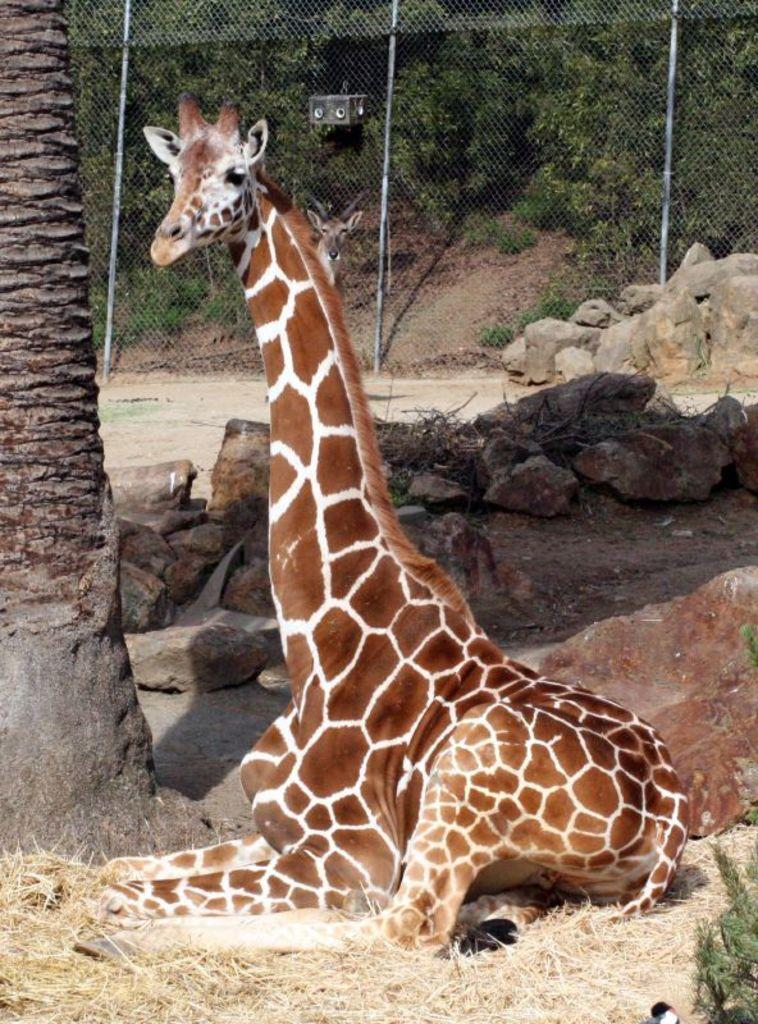What type of animal can be seen in the image? There is a giraffe in the image. What type of vegetation is visible in the image? Dry grass and plants are present in the image. What other objects can be seen in the image? Stones and a mesh are visible in the image. What part of a tree is visible in the image? A tree trunk is visible in the image. What year is depicted in the image? The image does not depict a specific year; it is a photograph of a giraffe, dry grass, stones, mesh, and a tree trunk. How many giraffes are present in the image? There is only one giraffe visible in the image. 